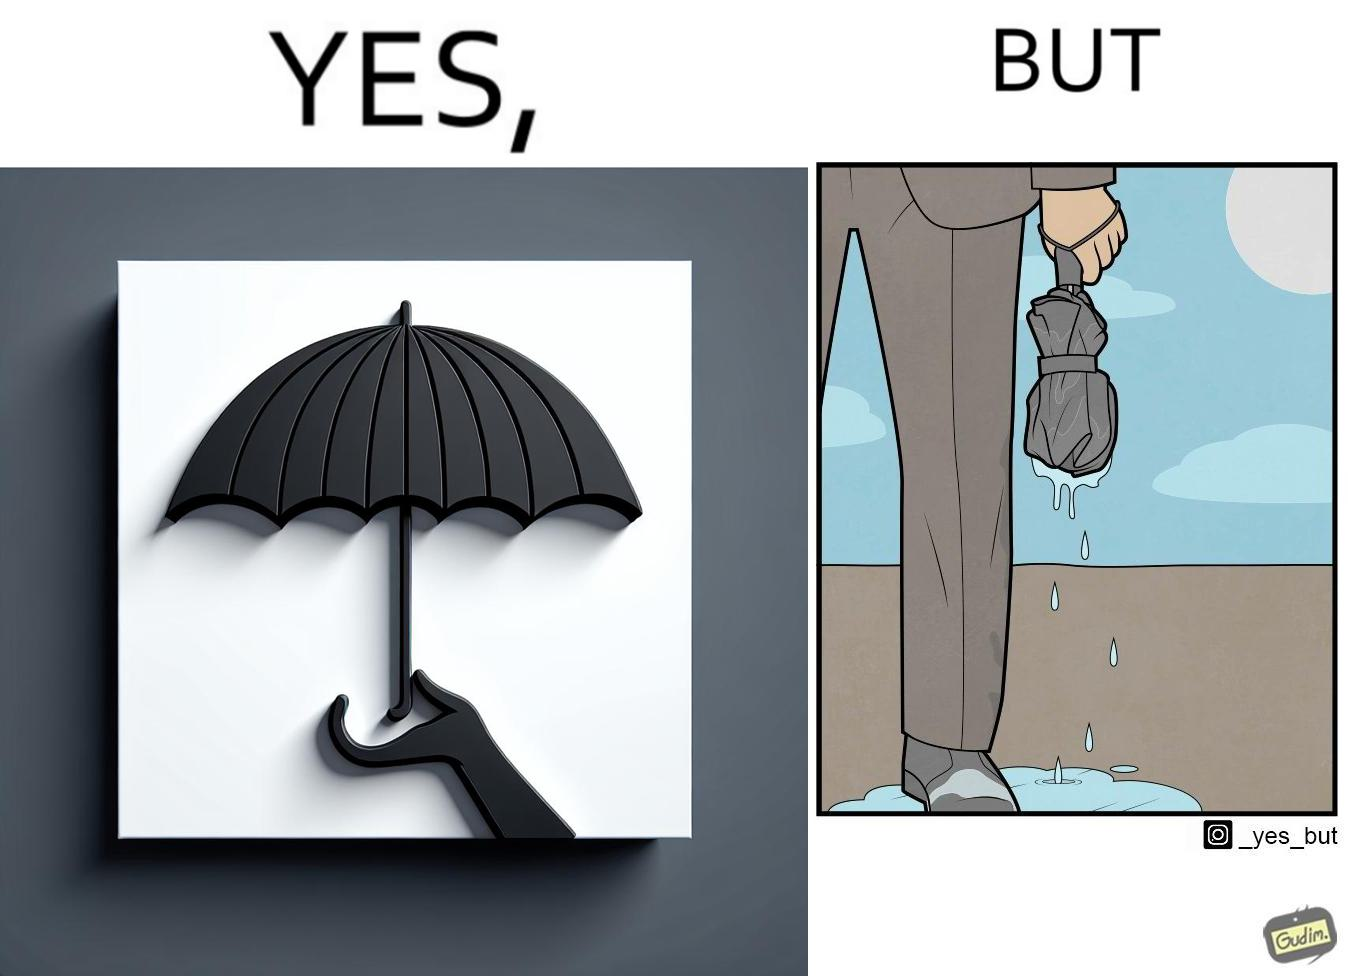Is there satirical content in this image? Yes, this image is satirical. 